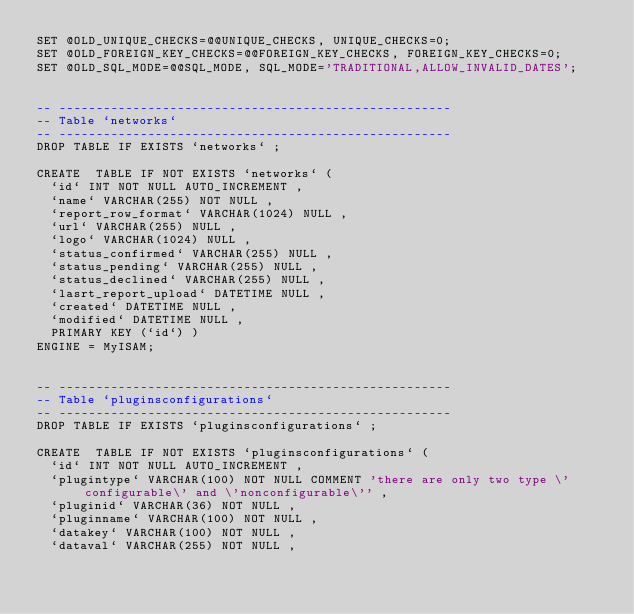<code> <loc_0><loc_0><loc_500><loc_500><_SQL_>SET @OLD_UNIQUE_CHECKS=@@UNIQUE_CHECKS, UNIQUE_CHECKS=0;
SET @OLD_FOREIGN_KEY_CHECKS=@@FOREIGN_KEY_CHECKS, FOREIGN_KEY_CHECKS=0;
SET @OLD_SQL_MODE=@@SQL_MODE, SQL_MODE='TRADITIONAL,ALLOW_INVALID_DATES';


-- -----------------------------------------------------
-- Table `networks`
-- -----------------------------------------------------
DROP TABLE IF EXISTS `networks` ;

CREATE  TABLE IF NOT EXISTS `networks` (
  `id` INT NOT NULL AUTO_INCREMENT ,
  `name` VARCHAR(255) NOT NULL ,
  `report_row_format` VARCHAR(1024) NULL ,
  `url` VARCHAR(255) NULL ,
  `logo` VARCHAR(1024) NULL ,
  `status_confirmed` VARCHAR(255) NULL ,
  `status_pending` VARCHAR(255) NULL ,
  `status_declined` VARCHAR(255) NULL ,
  `lasrt_report_upload` DATETIME NULL ,
  `created` DATETIME NULL ,
  `modified` DATETIME NULL ,
  PRIMARY KEY (`id`) )
ENGINE = MyISAM;


-- -----------------------------------------------------
-- Table `pluginsconfigurations`
-- -----------------------------------------------------
DROP TABLE IF EXISTS `pluginsconfigurations` ;

CREATE  TABLE IF NOT EXISTS `pluginsconfigurations` (
  `id` INT NOT NULL AUTO_INCREMENT ,
  `plugintype` VARCHAR(100) NOT NULL COMMENT 'there are only two type \'configurable\' and \'nonconfigurable\'' ,
  `pluginid` VARCHAR(36) NOT NULL ,
  `pluginname` VARCHAR(100) NOT NULL ,
  `datakey` VARCHAR(100) NOT NULL ,
  `dataval` VARCHAR(255) NOT NULL ,</code> 